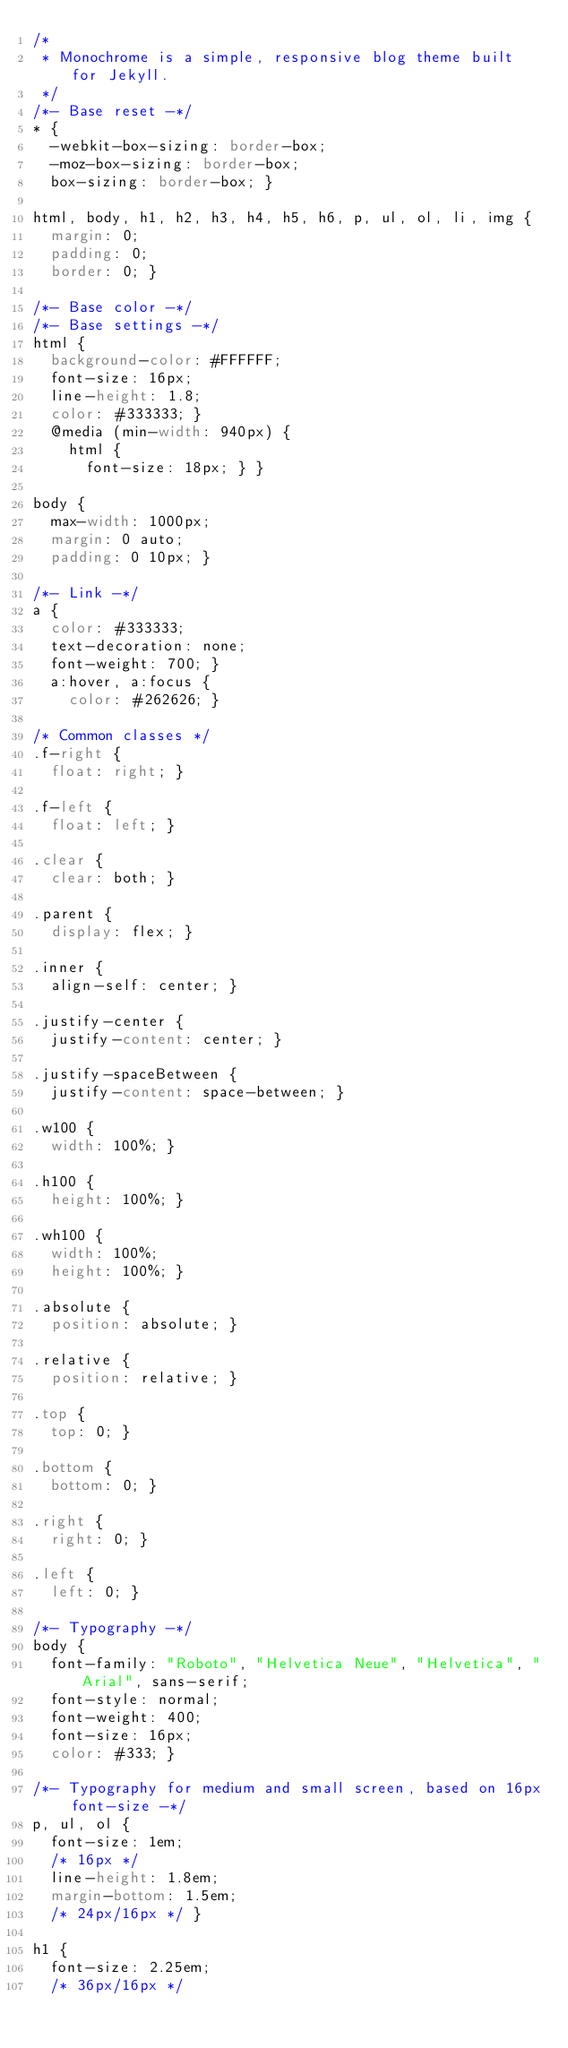Convert code to text. <code><loc_0><loc_0><loc_500><loc_500><_CSS_>/*
 * Monochrome is a simple, responsive blog theme built for Jekyll.
 */
/*- Base reset -*/
* {
  -webkit-box-sizing: border-box;
  -moz-box-sizing: border-box;
  box-sizing: border-box; }

html, body, h1, h2, h3, h4, h5, h6, p, ul, ol, li, img {
  margin: 0;
  padding: 0;
  border: 0; }

/*- Base color -*/
/*- Base settings -*/
html {
  background-color: #FFFFFF;
  font-size: 16px;
  line-height: 1.8;
  color: #333333; }
  @media (min-width: 940px) {
    html {
      font-size: 18px; } }

body {
  max-width: 1000px;
  margin: 0 auto;
  padding: 0 10px; }

/*- Link -*/
a {
  color: #333333;
  text-decoration: none;
  font-weight: 700; }
  a:hover, a:focus {
    color: #262626; }

/* Common classes */
.f-right {
  float: right; }

.f-left {
  float: left; }

.clear {
  clear: both; }

.parent {
  display: flex; }

.inner {
  align-self: center; }

.justify-center {
  justify-content: center; }

.justify-spaceBetween {
  justify-content: space-between; }

.w100 {
  width: 100%; }

.h100 {
  height: 100%; }

.wh100 {
  width: 100%;
  height: 100%; }

.absolute {
  position: absolute; }

.relative {
  position: relative; }

.top {
  top: 0; }

.bottom {
  bottom: 0; }

.right {
  right: 0; }

.left {
  left: 0; }

/*- Typography -*/
body {
  font-family: "Roboto", "Helvetica Neue", "Helvetica", "Arial", sans-serif;
  font-style: normal;
  font-weight: 400;
  font-size: 16px;
  color: #333; }

/*- Typography for medium and small screen, based on 16px font-size -*/
p, ul, ol {
  font-size: 1em;
  /* 16px */
  line-height: 1.8em;
  margin-bottom: 1.5em;
  /* 24px/16px */ }

h1 {
  font-size: 2.25em;
  /* 36px/16px */</code> 